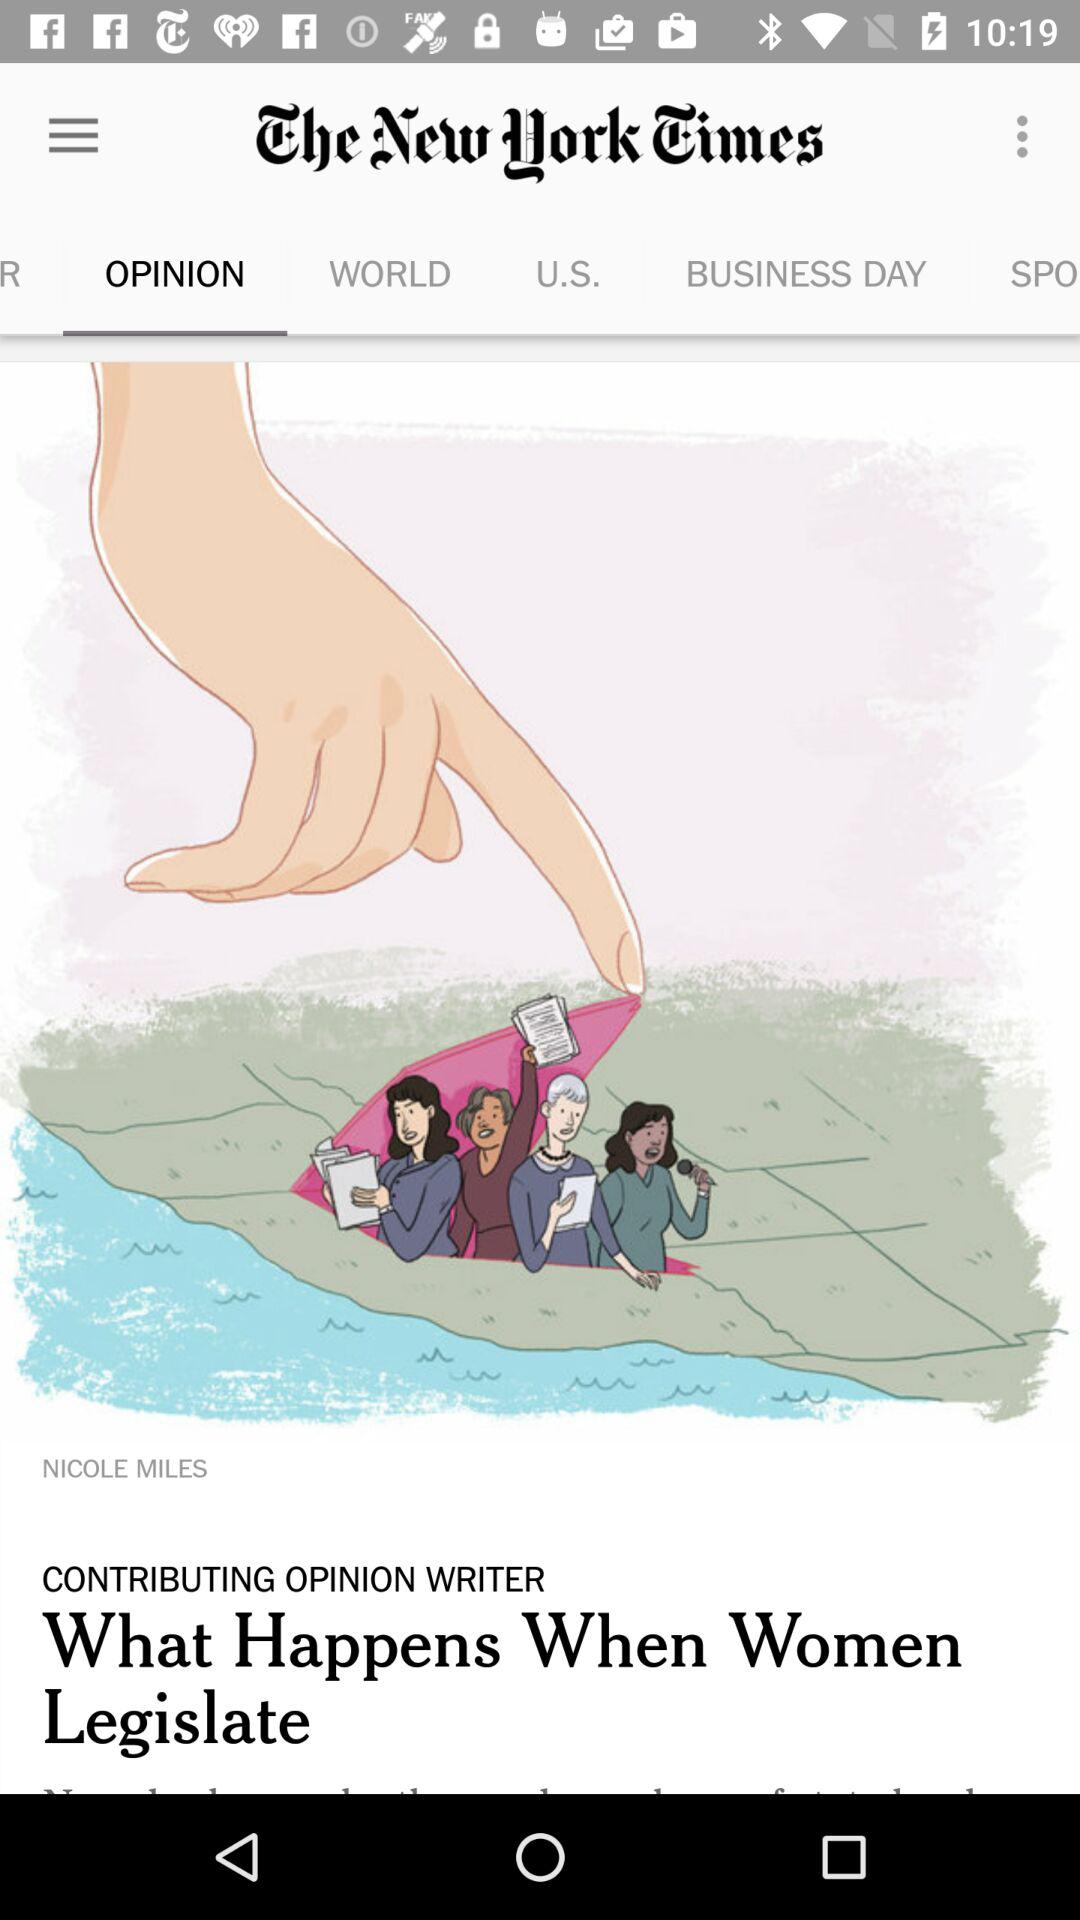Which tab am I using? You are using the tab "OPINION". 